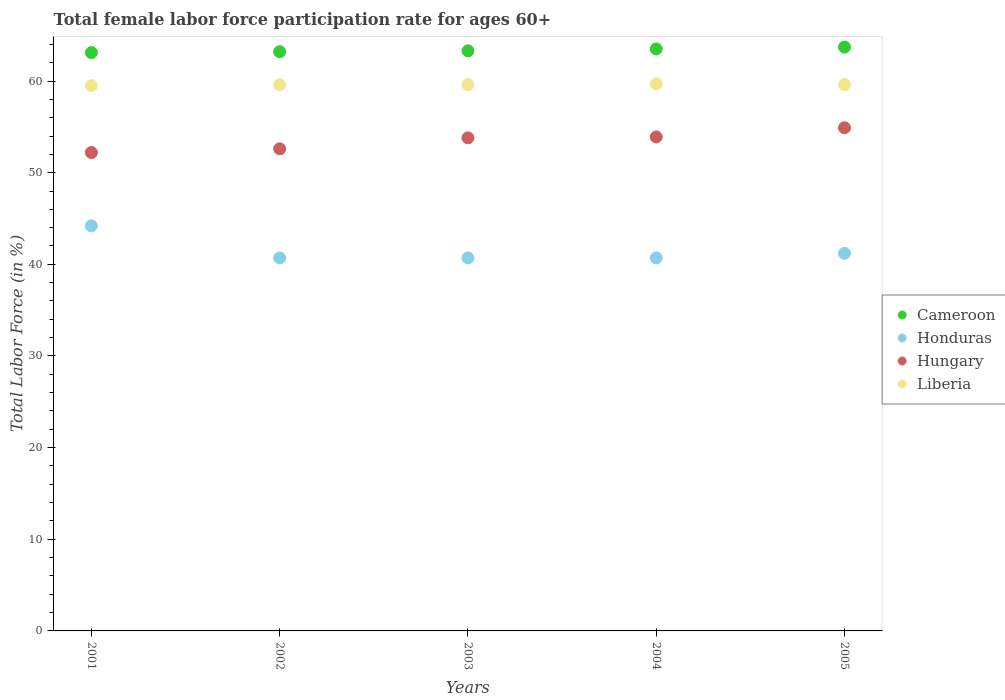What is the female labor force participation rate in Cameroon in 2002?
Give a very brief answer. 63.2. Across all years, what is the maximum female labor force participation rate in Hungary?
Make the answer very short. 54.9. Across all years, what is the minimum female labor force participation rate in Hungary?
Offer a very short reply. 52.2. In which year was the female labor force participation rate in Hungary maximum?
Give a very brief answer. 2005. What is the total female labor force participation rate in Liberia in the graph?
Offer a terse response. 298. What is the difference between the female labor force participation rate in Liberia in 2001 and that in 2005?
Offer a very short reply. -0.1. What is the difference between the female labor force participation rate in Hungary in 2004 and the female labor force participation rate in Honduras in 2001?
Your answer should be very brief. 9.7. What is the average female labor force participation rate in Liberia per year?
Offer a very short reply. 59.6. In how many years, is the female labor force participation rate in Honduras greater than 4 %?
Make the answer very short. 5. What is the ratio of the female labor force participation rate in Liberia in 2001 to that in 2002?
Ensure brevity in your answer.  1. Is the difference between the female labor force participation rate in Liberia in 2002 and 2003 greater than the difference between the female labor force participation rate in Hungary in 2002 and 2003?
Your answer should be compact. Yes. What is the difference between the highest and the second highest female labor force participation rate in Cameroon?
Offer a terse response. 0.2. What is the difference between the highest and the lowest female labor force participation rate in Cameroon?
Keep it short and to the point. 0.6. In how many years, is the female labor force participation rate in Hungary greater than the average female labor force participation rate in Hungary taken over all years?
Provide a short and direct response. 3. Is it the case that in every year, the sum of the female labor force participation rate in Cameroon and female labor force participation rate in Hungary  is greater than the female labor force participation rate in Liberia?
Give a very brief answer. Yes. Is the female labor force participation rate in Hungary strictly greater than the female labor force participation rate in Honduras over the years?
Keep it short and to the point. Yes. How many dotlines are there?
Provide a succinct answer. 4. What is the difference between two consecutive major ticks on the Y-axis?
Ensure brevity in your answer.  10. Does the graph contain any zero values?
Provide a short and direct response. No. Does the graph contain grids?
Provide a succinct answer. No. Where does the legend appear in the graph?
Ensure brevity in your answer.  Center right. What is the title of the graph?
Make the answer very short. Total female labor force participation rate for ages 60+. Does "Trinidad and Tobago" appear as one of the legend labels in the graph?
Offer a very short reply. No. What is the Total Labor Force (in %) in Cameroon in 2001?
Offer a terse response. 63.1. What is the Total Labor Force (in %) in Honduras in 2001?
Your answer should be very brief. 44.2. What is the Total Labor Force (in %) of Hungary in 2001?
Ensure brevity in your answer.  52.2. What is the Total Labor Force (in %) of Liberia in 2001?
Keep it short and to the point. 59.5. What is the Total Labor Force (in %) of Cameroon in 2002?
Provide a short and direct response. 63.2. What is the Total Labor Force (in %) in Honduras in 2002?
Your answer should be very brief. 40.7. What is the Total Labor Force (in %) in Hungary in 2002?
Provide a succinct answer. 52.6. What is the Total Labor Force (in %) in Liberia in 2002?
Give a very brief answer. 59.6. What is the Total Labor Force (in %) in Cameroon in 2003?
Offer a very short reply. 63.3. What is the Total Labor Force (in %) in Honduras in 2003?
Your response must be concise. 40.7. What is the Total Labor Force (in %) of Hungary in 2003?
Your answer should be very brief. 53.8. What is the Total Labor Force (in %) in Liberia in 2003?
Your answer should be very brief. 59.6. What is the Total Labor Force (in %) of Cameroon in 2004?
Give a very brief answer. 63.5. What is the Total Labor Force (in %) of Honduras in 2004?
Ensure brevity in your answer.  40.7. What is the Total Labor Force (in %) of Hungary in 2004?
Provide a short and direct response. 53.9. What is the Total Labor Force (in %) of Liberia in 2004?
Keep it short and to the point. 59.7. What is the Total Labor Force (in %) in Cameroon in 2005?
Offer a terse response. 63.7. What is the Total Labor Force (in %) of Honduras in 2005?
Provide a succinct answer. 41.2. What is the Total Labor Force (in %) in Hungary in 2005?
Offer a terse response. 54.9. What is the Total Labor Force (in %) in Liberia in 2005?
Provide a short and direct response. 59.6. Across all years, what is the maximum Total Labor Force (in %) in Cameroon?
Give a very brief answer. 63.7. Across all years, what is the maximum Total Labor Force (in %) in Honduras?
Offer a terse response. 44.2. Across all years, what is the maximum Total Labor Force (in %) of Hungary?
Give a very brief answer. 54.9. Across all years, what is the maximum Total Labor Force (in %) of Liberia?
Provide a short and direct response. 59.7. Across all years, what is the minimum Total Labor Force (in %) of Cameroon?
Give a very brief answer. 63.1. Across all years, what is the minimum Total Labor Force (in %) of Honduras?
Offer a very short reply. 40.7. Across all years, what is the minimum Total Labor Force (in %) of Hungary?
Your answer should be compact. 52.2. Across all years, what is the minimum Total Labor Force (in %) in Liberia?
Make the answer very short. 59.5. What is the total Total Labor Force (in %) in Cameroon in the graph?
Your answer should be very brief. 316.8. What is the total Total Labor Force (in %) in Honduras in the graph?
Your answer should be compact. 207.5. What is the total Total Labor Force (in %) in Hungary in the graph?
Give a very brief answer. 267.4. What is the total Total Labor Force (in %) of Liberia in the graph?
Provide a succinct answer. 298. What is the difference between the Total Labor Force (in %) of Honduras in 2001 and that in 2002?
Offer a terse response. 3.5. What is the difference between the Total Labor Force (in %) in Hungary in 2001 and that in 2002?
Offer a very short reply. -0.4. What is the difference between the Total Labor Force (in %) in Cameroon in 2001 and that in 2003?
Provide a succinct answer. -0.2. What is the difference between the Total Labor Force (in %) in Liberia in 2001 and that in 2003?
Ensure brevity in your answer.  -0.1. What is the difference between the Total Labor Force (in %) in Cameroon in 2001 and that in 2004?
Your answer should be very brief. -0.4. What is the difference between the Total Labor Force (in %) in Cameroon in 2001 and that in 2005?
Keep it short and to the point. -0.6. What is the difference between the Total Labor Force (in %) of Hungary in 2001 and that in 2005?
Offer a very short reply. -2.7. What is the difference between the Total Labor Force (in %) of Liberia in 2001 and that in 2005?
Your answer should be very brief. -0.1. What is the difference between the Total Labor Force (in %) of Hungary in 2002 and that in 2003?
Keep it short and to the point. -1.2. What is the difference between the Total Labor Force (in %) of Liberia in 2002 and that in 2004?
Ensure brevity in your answer.  -0.1. What is the difference between the Total Labor Force (in %) of Cameroon in 2002 and that in 2005?
Ensure brevity in your answer.  -0.5. What is the difference between the Total Labor Force (in %) of Liberia in 2002 and that in 2005?
Your answer should be very brief. 0. What is the difference between the Total Labor Force (in %) in Cameroon in 2003 and that in 2004?
Your answer should be compact. -0.2. What is the difference between the Total Labor Force (in %) of Honduras in 2003 and that in 2004?
Ensure brevity in your answer.  0. What is the difference between the Total Labor Force (in %) in Liberia in 2003 and that in 2004?
Your response must be concise. -0.1. What is the difference between the Total Labor Force (in %) of Honduras in 2003 and that in 2005?
Offer a very short reply. -0.5. What is the difference between the Total Labor Force (in %) in Hungary in 2004 and that in 2005?
Make the answer very short. -1. What is the difference between the Total Labor Force (in %) in Cameroon in 2001 and the Total Labor Force (in %) in Honduras in 2002?
Offer a terse response. 22.4. What is the difference between the Total Labor Force (in %) of Cameroon in 2001 and the Total Labor Force (in %) of Liberia in 2002?
Your response must be concise. 3.5. What is the difference between the Total Labor Force (in %) of Honduras in 2001 and the Total Labor Force (in %) of Hungary in 2002?
Your answer should be compact. -8.4. What is the difference between the Total Labor Force (in %) of Honduras in 2001 and the Total Labor Force (in %) of Liberia in 2002?
Ensure brevity in your answer.  -15.4. What is the difference between the Total Labor Force (in %) of Cameroon in 2001 and the Total Labor Force (in %) of Honduras in 2003?
Provide a succinct answer. 22.4. What is the difference between the Total Labor Force (in %) of Honduras in 2001 and the Total Labor Force (in %) of Hungary in 2003?
Offer a terse response. -9.6. What is the difference between the Total Labor Force (in %) in Honduras in 2001 and the Total Labor Force (in %) in Liberia in 2003?
Offer a very short reply. -15.4. What is the difference between the Total Labor Force (in %) in Hungary in 2001 and the Total Labor Force (in %) in Liberia in 2003?
Offer a very short reply. -7.4. What is the difference between the Total Labor Force (in %) of Cameroon in 2001 and the Total Labor Force (in %) of Honduras in 2004?
Make the answer very short. 22.4. What is the difference between the Total Labor Force (in %) in Cameroon in 2001 and the Total Labor Force (in %) in Hungary in 2004?
Provide a short and direct response. 9.2. What is the difference between the Total Labor Force (in %) in Honduras in 2001 and the Total Labor Force (in %) in Hungary in 2004?
Offer a terse response. -9.7. What is the difference between the Total Labor Force (in %) in Honduras in 2001 and the Total Labor Force (in %) in Liberia in 2004?
Keep it short and to the point. -15.5. What is the difference between the Total Labor Force (in %) of Cameroon in 2001 and the Total Labor Force (in %) of Honduras in 2005?
Your answer should be very brief. 21.9. What is the difference between the Total Labor Force (in %) in Honduras in 2001 and the Total Labor Force (in %) in Liberia in 2005?
Ensure brevity in your answer.  -15.4. What is the difference between the Total Labor Force (in %) of Cameroon in 2002 and the Total Labor Force (in %) of Honduras in 2003?
Make the answer very short. 22.5. What is the difference between the Total Labor Force (in %) in Cameroon in 2002 and the Total Labor Force (in %) in Hungary in 2003?
Your answer should be very brief. 9.4. What is the difference between the Total Labor Force (in %) in Cameroon in 2002 and the Total Labor Force (in %) in Liberia in 2003?
Your answer should be very brief. 3.6. What is the difference between the Total Labor Force (in %) of Honduras in 2002 and the Total Labor Force (in %) of Hungary in 2003?
Your answer should be very brief. -13.1. What is the difference between the Total Labor Force (in %) in Honduras in 2002 and the Total Labor Force (in %) in Liberia in 2003?
Keep it short and to the point. -18.9. What is the difference between the Total Labor Force (in %) of Hungary in 2002 and the Total Labor Force (in %) of Liberia in 2003?
Your response must be concise. -7. What is the difference between the Total Labor Force (in %) in Cameroon in 2002 and the Total Labor Force (in %) in Honduras in 2004?
Your response must be concise. 22.5. What is the difference between the Total Labor Force (in %) in Honduras in 2002 and the Total Labor Force (in %) in Hungary in 2004?
Your answer should be compact. -13.2. What is the difference between the Total Labor Force (in %) of Honduras in 2002 and the Total Labor Force (in %) of Liberia in 2004?
Provide a short and direct response. -19. What is the difference between the Total Labor Force (in %) in Cameroon in 2002 and the Total Labor Force (in %) in Honduras in 2005?
Offer a very short reply. 22. What is the difference between the Total Labor Force (in %) of Cameroon in 2002 and the Total Labor Force (in %) of Hungary in 2005?
Make the answer very short. 8.3. What is the difference between the Total Labor Force (in %) in Cameroon in 2002 and the Total Labor Force (in %) in Liberia in 2005?
Your answer should be compact. 3.6. What is the difference between the Total Labor Force (in %) in Honduras in 2002 and the Total Labor Force (in %) in Liberia in 2005?
Keep it short and to the point. -18.9. What is the difference between the Total Labor Force (in %) in Cameroon in 2003 and the Total Labor Force (in %) in Honduras in 2004?
Your answer should be very brief. 22.6. What is the difference between the Total Labor Force (in %) of Cameroon in 2003 and the Total Labor Force (in %) of Liberia in 2004?
Provide a succinct answer. 3.6. What is the difference between the Total Labor Force (in %) in Honduras in 2003 and the Total Labor Force (in %) in Liberia in 2004?
Provide a short and direct response. -19. What is the difference between the Total Labor Force (in %) in Hungary in 2003 and the Total Labor Force (in %) in Liberia in 2004?
Provide a succinct answer. -5.9. What is the difference between the Total Labor Force (in %) in Cameroon in 2003 and the Total Labor Force (in %) in Honduras in 2005?
Your response must be concise. 22.1. What is the difference between the Total Labor Force (in %) of Cameroon in 2003 and the Total Labor Force (in %) of Hungary in 2005?
Keep it short and to the point. 8.4. What is the difference between the Total Labor Force (in %) in Honduras in 2003 and the Total Labor Force (in %) in Liberia in 2005?
Offer a very short reply. -18.9. What is the difference between the Total Labor Force (in %) of Hungary in 2003 and the Total Labor Force (in %) of Liberia in 2005?
Ensure brevity in your answer.  -5.8. What is the difference between the Total Labor Force (in %) of Cameroon in 2004 and the Total Labor Force (in %) of Honduras in 2005?
Your answer should be compact. 22.3. What is the difference between the Total Labor Force (in %) in Cameroon in 2004 and the Total Labor Force (in %) in Hungary in 2005?
Ensure brevity in your answer.  8.6. What is the difference between the Total Labor Force (in %) of Cameroon in 2004 and the Total Labor Force (in %) of Liberia in 2005?
Your response must be concise. 3.9. What is the difference between the Total Labor Force (in %) in Honduras in 2004 and the Total Labor Force (in %) in Hungary in 2005?
Your response must be concise. -14.2. What is the difference between the Total Labor Force (in %) of Honduras in 2004 and the Total Labor Force (in %) of Liberia in 2005?
Ensure brevity in your answer.  -18.9. What is the average Total Labor Force (in %) in Cameroon per year?
Your response must be concise. 63.36. What is the average Total Labor Force (in %) in Honduras per year?
Offer a terse response. 41.5. What is the average Total Labor Force (in %) in Hungary per year?
Offer a very short reply. 53.48. What is the average Total Labor Force (in %) of Liberia per year?
Offer a very short reply. 59.6. In the year 2001, what is the difference between the Total Labor Force (in %) in Cameroon and Total Labor Force (in %) in Honduras?
Provide a short and direct response. 18.9. In the year 2001, what is the difference between the Total Labor Force (in %) in Honduras and Total Labor Force (in %) in Hungary?
Provide a short and direct response. -8. In the year 2001, what is the difference between the Total Labor Force (in %) in Honduras and Total Labor Force (in %) in Liberia?
Keep it short and to the point. -15.3. In the year 2002, what is the difference between the Total Labor Force (in %) in Cameroon and Total Labor Force (in %) in Honduras?
Your answer should be compact. 22.5. In the year 2002, what is the difference between the Total Labor Force (in %) in Cameroon and Total Labor Force (in %) in Hungary?
Your answer should be compact. 10.6. In the year 2002, what is the difference between the Total Labor Force (in %) in Honduras and Total Labor Force (in %) in Hungary?
Offer a terse response. -11.9. In the year 2002, what is the difference between the Total Labor Force (in %) of Honduras and Total Labor Force (in %) of Liberia?
Provide a short and direct response. -18.9. In the year 2003, what is the difference between the Total Labor Force (in %) in Cameroon and Total Labor Force (in %) in Honduras?
Give a very brief answer. 22.6. In the year 2003, what is the difference between the Total Labor Force (in %) in Cameroon and Total Labor Force (in %) in Hungary?
Your answer should be compact. 9.5. In the year 2003, what is the difference between the Total Labor Force (in %) in Cameroon and Total Labor Force (in %) in Liberia?
Provide a succinct answer. 3.7. In the year 2003, what is the difference between the Total Labor Force (in %) of Honduras and Total Labor Force (in %) of Hungary?
Make the answer very short. -13.1. In the year 2003, what is the difference between the Total Labor Force (in %) of Honduras and Total Labor Force (in %) of Liberia?
Provide a succinct answer. -18.9. In the year 2003, what is the difference between the Total Labor Force (in %) of Hungary and Total Labor Force (in %) of Liberia?
Keep it short and to the point. -5.8. In the year 2004, what is the difference between the Total Labor Force (in %) in Cameroon and Total Labor Force (in %) in Honduras?
Your answer should be compact. 22.8. In the year 2004, what is the difference between the Total Labor Force (in %) of Cameroon and Total Labor Force (in %) of Liberia?
Your response must be concise. 3.8. In the year 2004, what is the difference between the Total Labor Force (in %) of Hungary and Total Labor Force (in %) of Liberia?
Ensure brevity in your answer.  -5.8. In the year 2005, what is the difference between the Total Labor Force (in %) of Cameroon and Total Labor Force (in %) of Honduras?
Provide a succinct answer. 22.5. In the year 2005, what is the difference between the Total Labor Force (in %) in Honduras and Total Labor Force (in %) in Hungary?
Provide a succinct answer. -13.7. In the year 2005, what is the difference between the Total Labor Force (in %) of Honduras and Total Labor Force (in %) of Liberia?
Offer a very short reply. -18.4. What is the ratio of the Total Labor Force (in %) in Honduras in 2001 to that in 2002?
Keep it short and to the point. 1.09. What is the ratio of the Total Labor Force (in %) of Hungary in 2001 to that in 2002?
Your answer should be very brief. 0.99. What is the ratio of the Total Labor Force (in %) in Cameroon in 2001 to that in 2003?
Provide a succinct answer. 1. What is the ratio of the Total Labor Force (in %) of Honduras in 2001 to that in 2003?
Offer a very short reply. 1.09. What is the ratio of the Total Labor Force (in %) of Hungary in 2001 to that in 2003?
Your answer should be very brief. 0.97. What is the ratio of the Total Labor Force (in %) in Cameroon in 2001 to that in 2004?
Your answer should be very brief. 0.99. What is the ratio of the Total Labor Force (in %) of Honduras in 2001 to that in 2004?
Give a very brief answer. 1.09. What is the ratio of the Total Labor Force (in %) of Hungary in 2001 to that in 2004?
Make the answer very short. 0.97. What is the ratio of the Total Labor Force (in %) in Cameroon in 2001 to that in 2005?
Ensure brevity in your answer.  0.99. What is the ratio of the Total Labor Force (in %) in Honduras in 2001 to that in 2005?
Provide a succinct answer. 1.07. What is the ratio of the Total Labor Force (in %) of Hungary in 2001 to that in 2005?
Your answer should be compact. 0.95. What is the ratio of the Total Labor Force (in %) in Hungary in 2002 to that in 2003?
Give a very brief answer. 0.98. What is the ratio of the Total Labor Force (in %) of Cameroon in 2002 to that in 2004?
Your answer should be compact. 1. What is the ratio of the Total Labor Force (in %) of Honduras in 2002 to that in 2004?
Keep it short and to the point. 1. What is the ratio of the Total Labor Force (in %) in Hungary in 2002 to that in 2004?
Your answer should be very brief. 0.98. What is the ratio of the Total Labor Force (in %) of Liberia in 2002 to that in 2004?
Keep it short and to the point. 1. What is the ratio of the Total Labor Force (in %) in Honduras in 2002 to that in 2005?
Provide a succinct answer. 0.99. What is the ratio of the Total Labor Force (in %) of Hungary in 2002 to that in 2005?
Provide a succinct answer. 0.96. What is the ratio of the Total Labor Force (in %) of Liberia in 2002 to that in 2005?
Offer a very short reply. 1. What is the ratio of the Total Labor Force (in %) in Cameroon in 2003 to that in 2004?
Your answer should be very brief. 1. What is the ratio of the Total Labor Force (in %) of Honduras in 2003 to that in 2004?
Provide a short and direct response. 1. What is the ratio of the Total Labor Force (in %) in Hungary in 2003 to that in 2004?
Ensure brevity in your answer.  1. What is the ratio of the Total Labor Force (in %) of Liberia in 2003 to that in 2004?
Offer a very short reply. 1. What is the ratio of the Total Labor Force (in %) of Cameroon in 2003 to that in 2005?
Ensure brevity in your answer.  0.99. What is the ratio of the Total Labor Force (in %) in Honduras in 2003 to that in 2005?
Provide a short and direct response. 0.99. What is the ratio of the Total Labor Force (in %) of Cameroon in 2004 to that in 2005?
Provide a succinct answer. 1. What is the ratio of the Total Labor Force (in %) of Honduras in 2004 to that in 2005?
Your answer should be very brief. 0.99. What is the ratio of the Total Labor Force (in %) in Hungary in 2004 to that in 2005?
Offer a very short reply. 0.98. What is the difference between the highest and the second highest Total Labor Force (in %) in Cameroon?
Offer a terse response. 0.2. What is the difference between the highest and the second highest Total Labor Force (in %) of Hungary?
Your response must be concise. 1. What is the difference between the highest and the second highest Total Labor Force (in %) in Liberia?
Offer a very short reply. 0.1. What is the difference between the highest and the lowest Total Labor Force (in %) of Cameroon?
Provide a short and direct response. 0.6. 